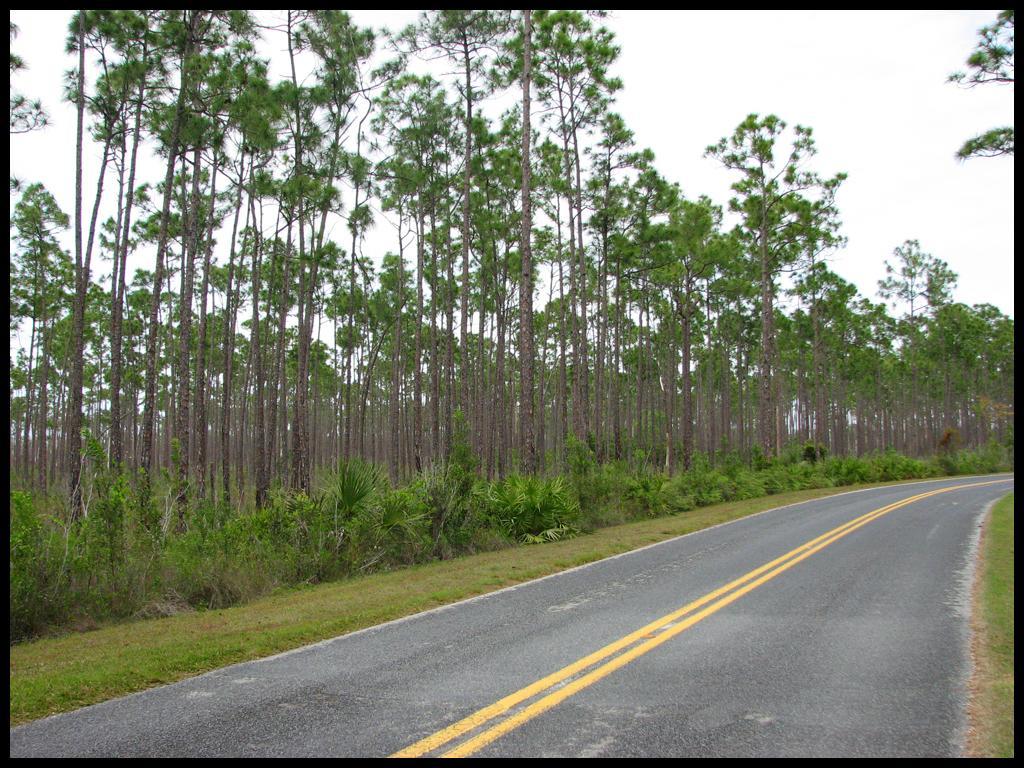Please provide a concise description of this image. In this image, we can see a road, there are some green color plants and trees, at the top there is a sky. 